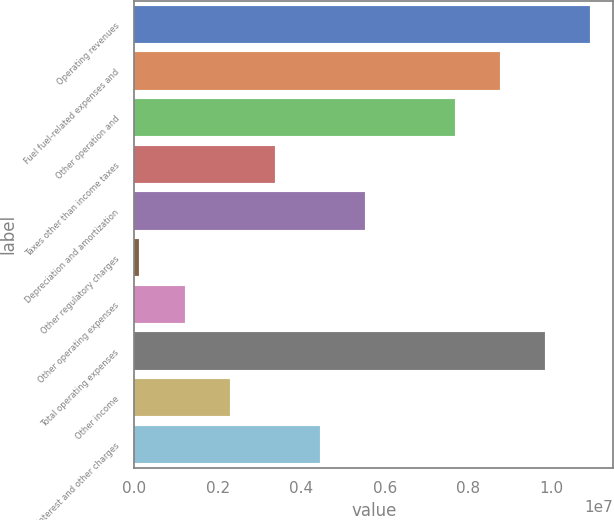<chart> <loc_0><loc_0><loc_500><loc_500><bar_chart><fcel>Operating revenues<fcel>Fuel fuel-related expenses and<fcel>Other operation and<fcel>Taxes other than income taxes<fcel>Depreciation and amortization<fcel>Other regulatory charges<fcel>Other operating expenses<fcel>Total operating expenses<fcel>Other income<fcel>Interest and other charges<nl><fcel>1.09322e+07<fcel>8.77026e+06<fcel>7.68931e+06<fcel>3.36552e+06<fcel>5.52742e+06<fcel>122680<fcel>1.20363e+06<fcel>9.85121e+06<fcel>2.28458e+06<fcel>4.44647e+06<nl></chart> 